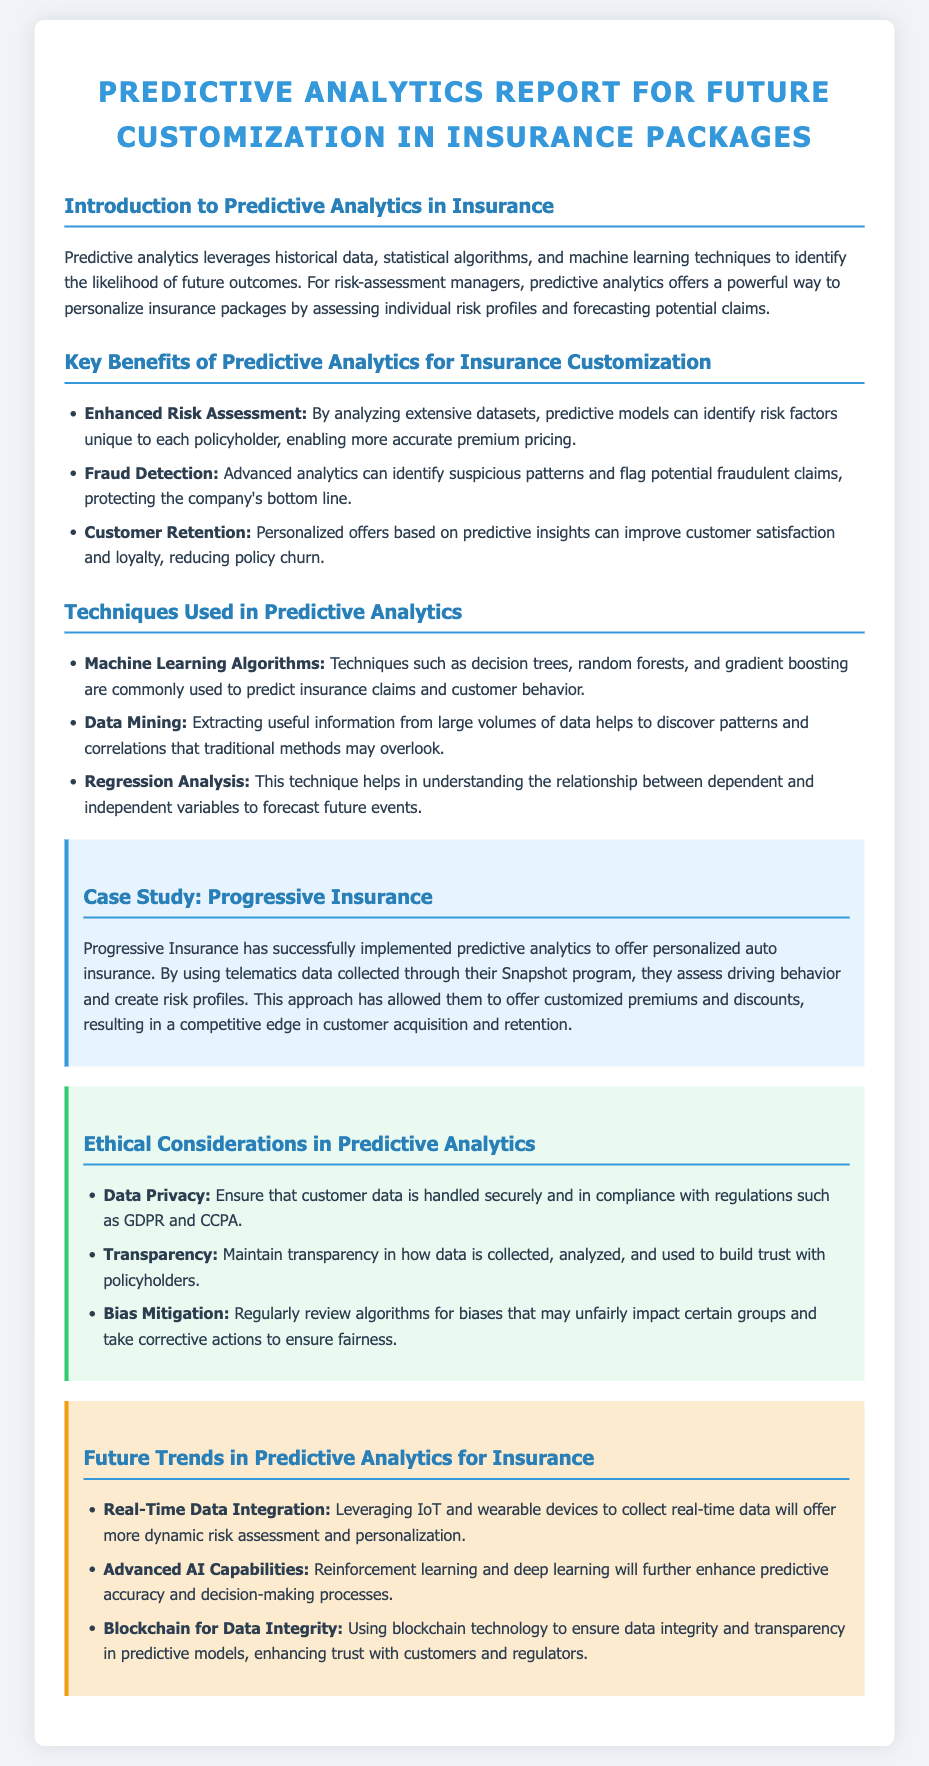what is the title of the report? The title of the report is given as the main heading at the top of the document.
Answer: Predictive Analytics Report for Future Customization in Insurance Packages what are the three key benefits of predictive analytics for insurance customization? The benefits are listed in a bulleted format in the document.
Answer: Enhanced Risk Assessment, Fraud Detection, Customer Retention which case study is mentioned in the report? The case study section specifically names a company that has implemented predictive analytics successfully.
Answer: Progressive Insurance what techniques are used in predictive analytics? The document lists several techniques in a section on techniques; these techniques reflect the methods used in predictive analytics.
Answer: Machine Learning Algorithms, Data Mining, Regression Analysis what ethical consideration addresses customer data security? The ethical considerations section points out crucial aspects of handling customer data responsibly.
Answer: Data Privacy what trend in predictive analytics involves real-time data collection? The future trends section indicates a growing trend in using technology for more dynamic assessments.
Answer: Real-Time Data Integration which advanced analytics technique is noted for enhancing predictive accuracy? The document specifies a type of technology under the future trends that improves predictive capabilities.
Answer: Advanced AI Capabilities how does Progressive Insurance offer customized premiums? The case study explains the specific method used by this insurance company to tailor their product offerings.
Answer: By using telematics data what is one example of a data regulation mentioned in the ethical considerations? The ethical considerations highlight specific regulations related to customer data handling.
Answer: GDPR 